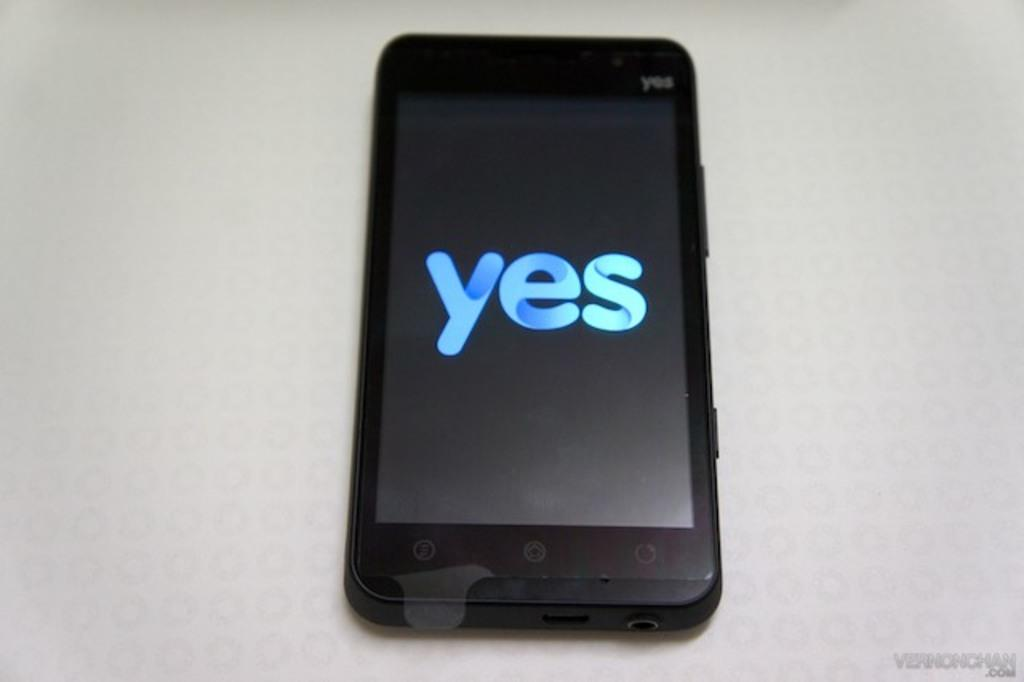<image>
Write a terse but informative summary of the picture. a black YES cell phone has a blue display reading YES 